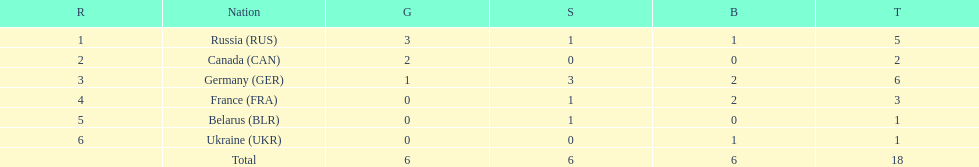Which country won more total medals than tue french, but less than the germans in the 1994 winter olympic biathlon? Russia. 